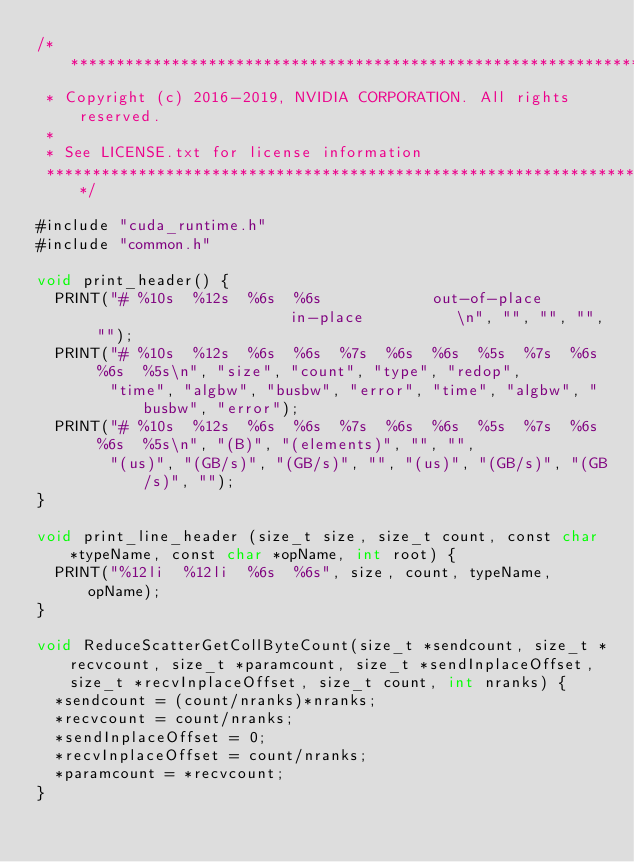Convert code to text. <code><loc_0><loc_0><loc_500><loc_500><_Cuda_>/*************************************************************************
 * Copyright (c) 2016-2019, NVIDIA CORPORATION. All rights reserved.
 *
 * See LICENSE.txt for license information
 ************************************************************************/

#include "cuda_runtime.h"
#include "common.h"

void print_header() {
  PRINT("# %10s  %12s  %6s  %6s            out-of-place                       in-place          \n", "", "", "", "");
  PRINT("# %10s  %12s  %6s  %6s  %7s  %6s  %6s  %5s  %7s  %6s  %6s  %5s\n", "size", "count", "type", "redop",
        "time", "algbw", "busbw", "error", "time", "algbw", "busbw", "error");
  PRINT("# %10s  %12s  %6s  %6s  %7s  %6s  %6s  %5s  %7s  %6s  %6s  %5s\n", "(B)", "(elements)", "", "",
        "(us)", "(GB/s)", "(GB/s)", "", "(us)", "(GB/s)", "(GB/s)", "");
}

void print_line_header (size_t size, size_t count, const char *typeName, const char *opName, int root) {
  PRINT("%12li  %12li  %6s  %6s", size, count, typeName, opName);
}

void ReduceScatterGetCollByteCount(size_t *sendcount, size_t *recvcount, size_t *paramcount, size_t *sendInplaceOffset, size_t *recvInplaceOffset, size_t count, int nranks) {
  *sendcount = (count/nranks)*nranks;
  *recvcount = count/nranks;
  *sendInplaceOffset = 0;
  *recvInplaceOffset = count/nranks;
  *paramcount = *recvcount;
}
</code> 